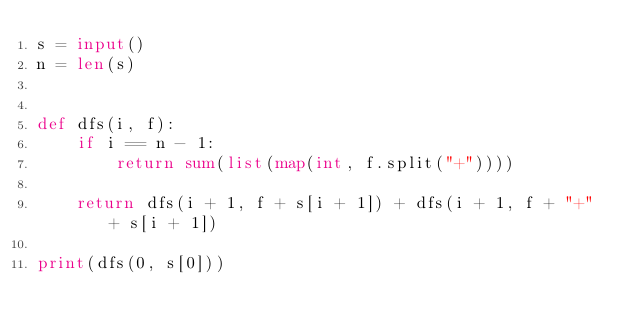Convert code to text. <code><loc_0><loc_0><loc_500><loc_500><_Python_>s = input()
n = len(s)


def dfs(i, f):
    if i == n - 1:
        return sum(list(map(int, f.split("+"))))

	return dfs(i + 1, f + s[i + 1]) + dfs(i + 1, f + "+" + s[i + 1])
    
print(dfs(0, s[0]))</code> 